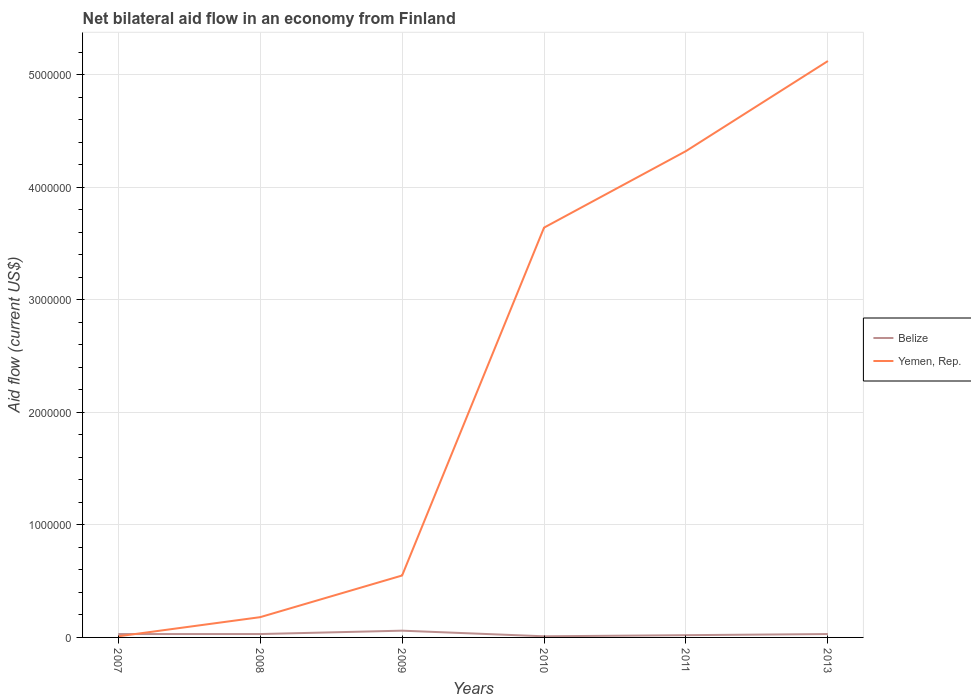How many different coloured lines are there?
Offer a terse response. 2. Is the number of lines equal to the number of legend labels?
Offer a terse response. Yes. In which year was the net bilateral aid flow in Belize maximum?
Your answer should be very brief. 2010. What is the total net bilateral aid flow in Belize in the graph?
Offer a very short reply. 0. What is the difference between the highest and the second highest net bilateral aid flow in Belize?
Make the answer very short. 5.00e+04. Is the net bilateral aid flow in Yemen, Rep. strictly greater than the net bilateral aid flow in Belize over the years?
Your answer should be compact. No. How many years are there in the graph?
Offer a terse response. 6. What is the difference between two consecutive major ticks on the Y-axis?
Offer a very short reply. 1.00e+06. Does the graph contain grids?
Offer a very short reply. Yes. Where does the legend appear in the graph?
Keep it short and to the point. Center right. How are the legend labels stacked?
Your answer should be compact. Vertical. What is the title of the graph?
Your answer should be compact. Net bilateral aid flow in an economy from Finland. What is the Aid flow (current US$) in Belize in 2007?
Make the answer very short. 3.00e+04. What is the Aid flow (current US$) of Yemen, Rep. in 2007?
Make the answer very short. 10000. What is the Aid flow (current US$) of Belize in 2008?
Provide a succinct answer. 3.00e+04. What is the Aid flow (current US$) of Yemen, Rep. in 2009?
Your answer should be compact. 5.50e+05. What is the Aid flow (current US$) of Yemen, Rep. in 2010?
Your response must be concise. 3.64e+06. What is the Aid flow (current US$) of Yemen, Rep. in 2011?
Provide a succinct answer. 4.32e+06. What is the Aid flow (current US$) of Yemen, Rep. in 2013?
Provide a succinct answer. 5.12e+06. Across all years, what is the maximum Aid flow (current US$) of Yemen, Rep.?
Offer a very short reply. 5.12e+06. Across all years, what is the minimum Aid flow (current US$) of Belize?
Your response must be concise. 10000. Across all years, what is the minimum Aid flow (current US$) in Yemen, Rep.?
Your answer should be very brief. 10000. What is the total Aid flow (current US$) in Belize in the graph?
Your answer should be very brief. 1.80e+05. What is the total Aid flow (current US$) in Yemen, Rep. in the graph?
Provide a succinct answer. 1.38e+07. What is the difference between the Aid flow (current US$) in Belize in 2007 and that in 2008?
Provide a succinct answer. 0. What is the difference between the Aid flow (current US$) of Yemen, Rep. in 2007 and that in 2008?
Make the answer very short. -1.70e+05. What is the difference between the Aid flow (current US$) in Belize in 2007 and that in 2009?
Ensure brevity in your answer.  -3.00e+04. What is the difference between the Aid flow (current US$) of Yemen, Rep. in 2007 and that in 2009?
Provide a short and direct response. -5.40e+05. What is the difference between the Aid flow (current US$) in Yemen, Rep. in 2007 and that in 2010?
Your answer should be compact. -3.63e+06. What is the difference between the Aid flow (current US$) in Yemen, Rep. in 2007 and that in 2011?
Provide a short and direct response. -4.31e+06. What is the difference between the Aid flow (current US$) of Yemen, Rep. in 2007 and that in 2013?
Your response must be concise. -5.11e+06. What is the difference between the Aid flow (current US$) in Yemen, Rep. in 2008 and that in 2009?
Keep it short and to the point. -3.70e+05. What is the difference between the Aid flow (current US$) in Belize in 2008 and that in 2010?
Provide a succinct answer. 2.00e+04. What is the difference between the Aid flow (current US$) in Yemen, Rep. in 2008 and that in 2010?
Your answer should be very brief. -3.46e+06. What is the difference between the Aid flow (current US$) of Yemen, Rep. in 2008 and that in 2011?
Give a very brief answer. -4.14e+06. What is the difference between the Aid flow (current US$) of Yemen, Rep. in 2008 and that in 2013?
Provide a succinct answer. -4.94e+06. What is the difference between the Aid flow (current US$) in Yemen, Rep. in 2009 and that in 2010?
Provide a short and direct response. -3.09e+06. What is the difference between the Aid flow (current US$) of Yemen, Rep. in 2009 and that in 2011?
Offer a very short reply. -3.77e+06. What is the difference between the Aid flow (current US$) of Yemen, Rep. in 2009 and that in 2013?
Your response must be concise. -4.57e+06. What is the difference between the Aid flow (current US$) in Belize in 2010 and that in 2011?
Make the answer very short. -10000. What is the difference between the Aid flow (current US$) of Yemen, Rep. in 2010 and that in 2011?
Make the answer very short. -6.80e+05. What is the difference between the Aid flow (current US$) in Belize in 2010 and that in 2013?
Make the answer very short. -2.00e+04. What is the difference between the Aid flow (current US$) in Yemen, Rep. in 2010 and that in 2013?
Your answer should be compact. -1.48e+06. What is the difference between the Aid flow (current US$) in Yemen, Rep. in 2011 and that in 2013?
Make the answer very short. -8.00e+05. What is the difference between the Aid flow (current US$) in Belize in 2007 and the Aid flow (current US$) in Yemen, Rep. in 2008?
Offer a very short reply. -1.50e+05. What is the difference between the Aid flow (current US$) of Belize in 2007 and the Aid flow (current US$) of Yemen, Rep. in 2009?
Offer a very short reply. -5.20e+05. What is the difference between the Aid flow (current US$) of Belize in 2007 and the Aid flow (current US$) of Yemen, Rep. in 2010?
Your answer should be compact. -3.61e+06. What is the difference between the Aid flow (current US$) in Belize in 2007 and the Aid flow (current US$) in Yemen, Rep. in 2011?
Keep it short and to the point. -4.29e+06. What is the difference between the Aid flow (current US$) in Belize in 2007 and the Aid flow (current US$) in Yemen, Rep. in 2013?
Your response must be concise. -5.09e+06. What is the difference between the Aid flow (current US$) of Belize in 2008 and the Aid flow (current US$) of Yemen, Rep. in 2009?
Your answer should be compact. -5.20e+05. What is the difference between the Aid flow (current US$) in Belize in 2008 and the Aid flow (current US$) in Yemen, Rep. in 2010?
Provide a succinct answer. -3.61e+06. What is the difference between the Aid flow (current US$) of Belize in 2008 and the Aid flow (current US$) of Yemen, Rep. in 2011?
Keep it short and to the point. -4.29e+06. What is the difference between the Aid flow (current US$) of Belize in 2008 and the Aid flow (current US$) of Yemen, Rep. in 2013?
Ensure brevity in your answer.  -5.09e+06. What is the difference between the Aid flow (current US$) of Belize in 2009 and the Aid flow (current US$) of Yemen, Rep. in 2010?
Provide a short and direct response. -3.58e+06. What is the difference between the Aid flow (current US$) in Belize in 2009 and the Aid flow (current US$) in Yemen, Rep. in 2011?
Give a very brief answer. -4.26e+06. What is the difference between the Aid flow (current US$) in Belize in 2009 and the Aid flow (current US$) in Yemen, Rep. in 2013?
Make the answer very short. -5.06e+06. What is the difference between the Aid flow (current US$) of Belize in 2010 and the Aid flow (current US$) of Yemen, Rep. in 2011?
Make the answer very short. -4.31e+06. What is the difference between the Aid flow (current US$) of Belize in 2010 and the Aid flow (current US$) of Yemen, Rep. in 2013?
Offer a very short reply. -5.11e+06. What is the difference between the Aid flow (current US$) in Belize in 2011 and the Aid flow (current US$) in Yemen, Rep. in 2013?
Make the answer very short. -5.10e+06. What is the average Aid flow (current US$) in Yemen, Rep. per year?
Your answer should be very brief. 2.30e+06. In the year 2007, what is the difference between the Aid flow (current US$) of Belize and Aid flow (current US$) of Yemen, Rep.?
Keep it short and to the point. 2.00e+04. In the year 2008, what is the difference between the Aid flow (current US$) in Belize and Aid flow (current US$) in Yemen, Rep.?
Provide a succinct answer. -1.50e+05. In the year 2009, what is the difference between the Aid flow (current US$) in Belize and Aid flow (current US$) in Yemen, Rep.?
Provide a short and direct response. -4.90e+05. In the year 2010, what is the difference between the Aid flow (current US$) of Belize and Aid flow (current US$) of Yemen, Rep.?
Keep it short and to the point. -3.63e+06. In the year 2011, what is the difference between the Aid flow (current US$) of Belize and Aid flow (current US$) of Yemen, Rep.?
Provide a succinct answer. -4.30e+06. In the year 2013, what is the difference between the Aid flow (current US$) in Belize and Aid flow (current US$) in Yemen, Rep.?
Offer a very short reply. -5.09e+06. What is the ratio of the Aid flow (current US$) of Yemen, Rep. in 2007 to that in 2008?
Your response must be concise. 0.06. What is the ratio of the Aid flow (current US$) of Belize in 2007 to that in 2009?
Ensure brevity in your answer.  0.5. What is the ratio of the Aid flow (current US$) in Yemen, Rep. in 2007 to that in 2009?
Keep it short and to the point. 0.02. What is the ratio of the Aid flow (current US$) of Belize in 2007 to that in 2010?
Your answer should be compact. 3. What is the ratio of the Aid flow (current US$) in Yemen, Rep. in 2007 to that in 2010?
Keep it short and to the point. 0. What is the ratio of the Aid flow (current US$) in Yemen, Rep. in 2007 to that in 2011?
Your response must be concise. 0. What is the ratio of the Aid flow (current US$) of Belize in 2007 to that in 2013?
Your answer should be very brief. 1. What is the ratio of the Aid flow (current US$) of Yemen, Rep. in 2007 to that in 2013?
Make the answer very short. 0. What is the ratio of the Aid flow (current US$) of Belize in 2008 to that in 2009?
Give a very brief answer. 0.5. What is the ratio of the Aid flow (current US$) in Yemen, Rep. in 2008 to that in 2009?
Your answer should be compact. 0.33. What is the ratio of the Aid flow (current US$) of Yemen, Rep. in 2008 to that in 2010?
Provide a succinct answer. 0.05. What is the ratio of the Aid flow (current US$) in Belize in 2008 to that in 2011?
Provide a short and direct response. 1.5. What is the ratio of the Aid flow (current US$) in Yemen, Rep. in 2008 to that in 2011?
Provide a short and direct response. 0.04. What is the ratio of the Aid flow (current US$) in Belize in 2008 to that in 2013?
Provide a succinct answer. 1. What is the ratio of the Aid flow (current US$) in Yemen, Rep. in 2008 to that in 2013?
Give a very brief answer. 0.04. What is the ratio of the Aid flow (current US$) in Belize in 2009 to that in 2010?
Provide a succinct answer. 6. What is the ratio of the Aid flow (current US$) of Yemen, Rep. in 2009 to that in 2010?
Keep it short and to the point. 0.15. What is the ratio of the Aid flow (current US$) of Belize in 2009 to that in 2011?
Your answer should be very brief. 3. What is the ratio of the Aid flow (current US$) in Yemen, Rep. in 2009 to that in 2011?
Your response must be concise. 0.13. What is the ratio of the Aid flow (current US$) of Belize in 2009 to that in 2013?
Provide a short and direct response. 2. What is the ratio of the Aid flow (current US$) in Yemen, Rep. in 2009 to that in 2013?
Make the answer very short. 0.11. What is the ratio of the Aid flow (current US$) of Yemen, Rep. in 2010 to that in 2011?
Your answer should be compact. 0.84. What is the ratio of the Aid flow (current US$) in Yemen, Rep. in 2010 to that in 2013?
Your answer should be compact. 0.71. What is the ratio of the Aid flow (current US$) in Yemen, Rep. in 2011 to that in 2013?
Offer a terse response. 0.84. What is the difference between the highest and the lowest Aid flow (current US$) of Belize?
Your answer should be compact. 5.00e+04. What is the difference between the highest and the lowest Aid flow (current US$) in Yemen, Rep.?
Give a very brief answer. 5.11e+06. 